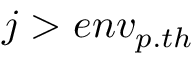<formula> <loc_0><loc_0><loc_500><loc_500>j > e n v _ { p . t h }</formula> 